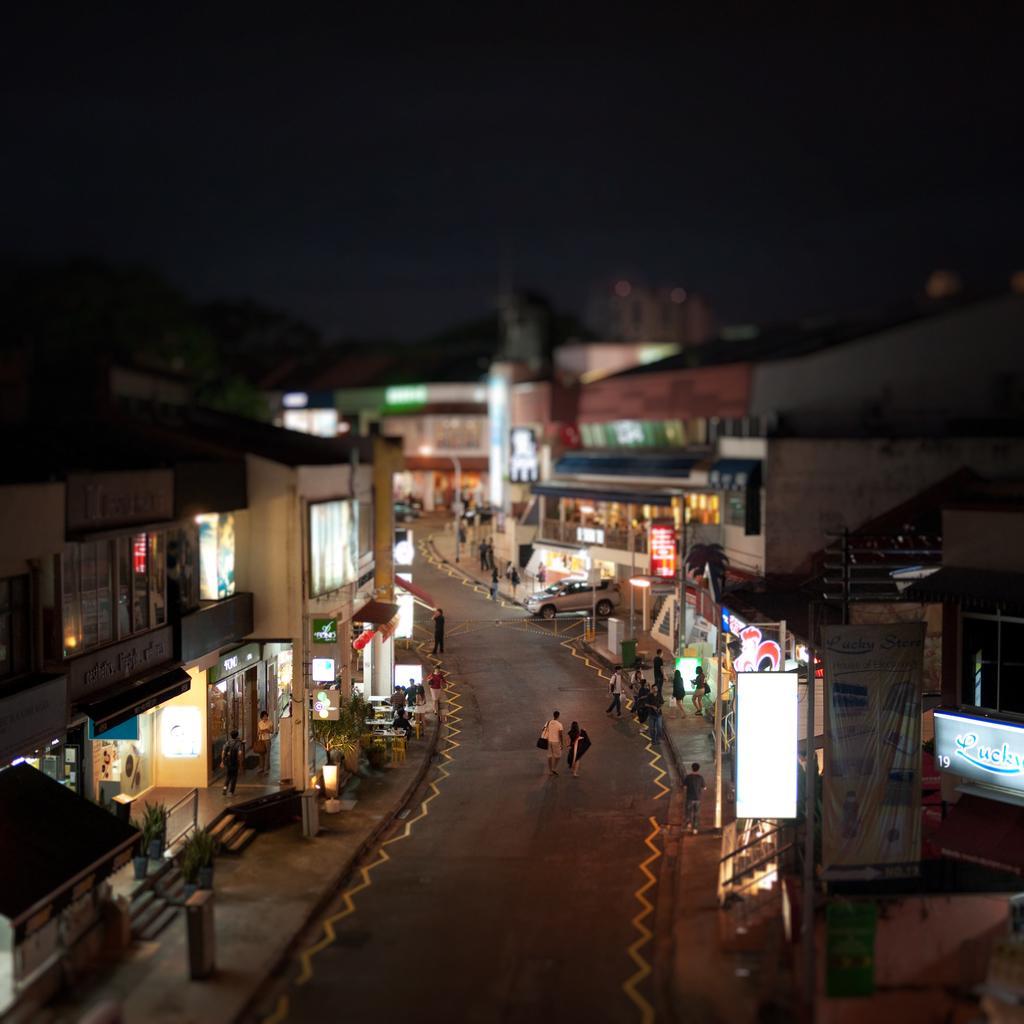In one or two sentences, can you explain what this image depicts? In this picture there are people in the image and there are stalls and posters on the right and left side of the image, it seems to be the picture is captured during night time and there are vehicles in the image. 